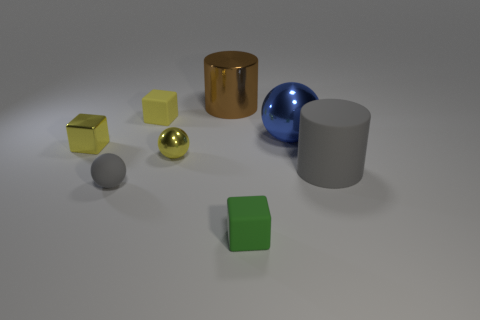Add 2 tiny green matte cubes. How many objects exist? 10 Subtract all cylinders. How many objects are left? 6 Subtract 2 cubes. How many cubes are left? 1 Subtract all green blocks. Subtract all gray spheres. How many blocks are left? 2 Subtract all yellow spheres. How many green cubes are left? 1 Subtract all brown cylinders. Subtract all small rubber things. How many objects are left? 4 Add 1 tiny blocks. How many tiny blocks are left? 4 Add 8 cyan shiny things. How many cyan shiny things exist? 8 Subtract all yellow cubes. How many cubes are left? 1 Subtract all gray rubber spheres. How many spheres are left? 2 